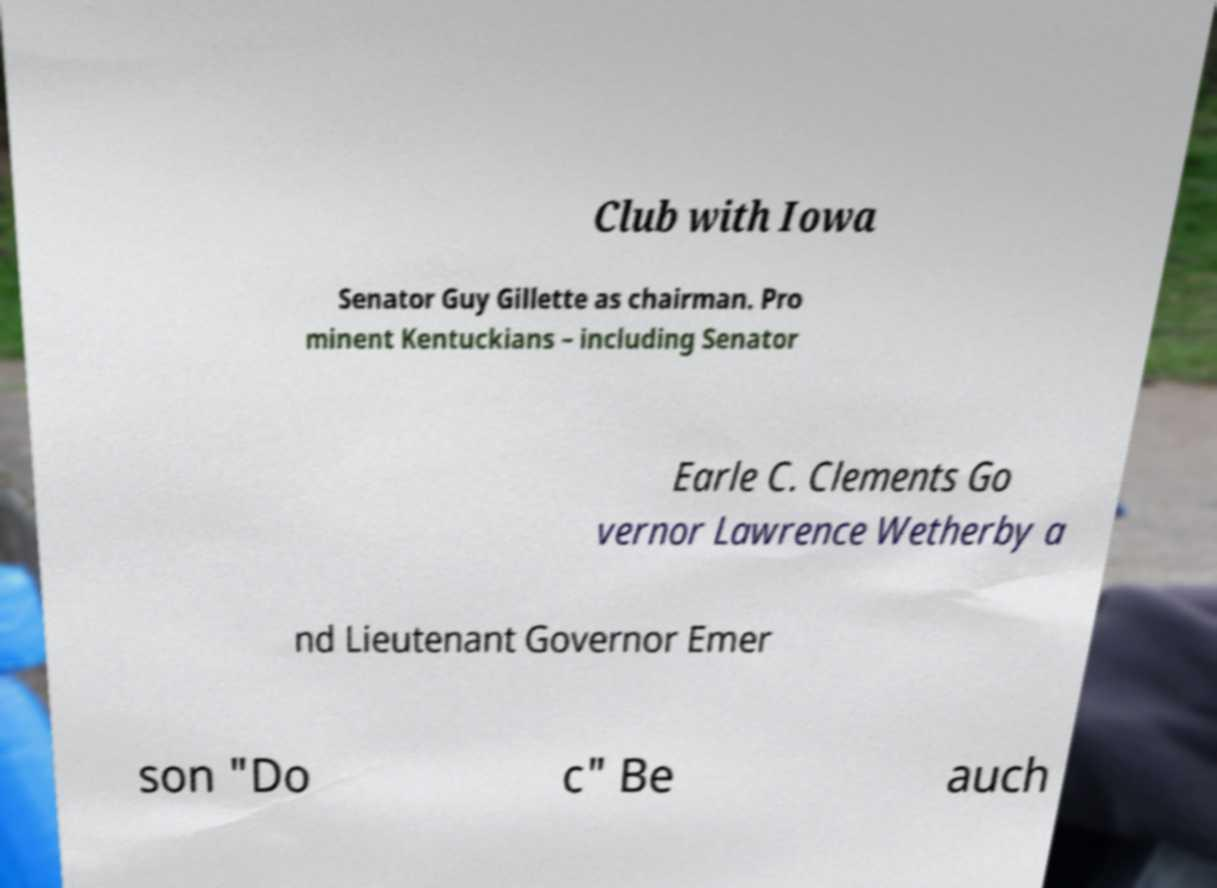I need the written content from this picture converted into text. Can you do that? Club with Iowa Senator Guy Gillette as chairman. Pro minent Kentuckians – including Senator Earle C. Clements Go vernor Lawrence Wetherby a nd Lieutenant Governor Emer son "Do c" Be auch 